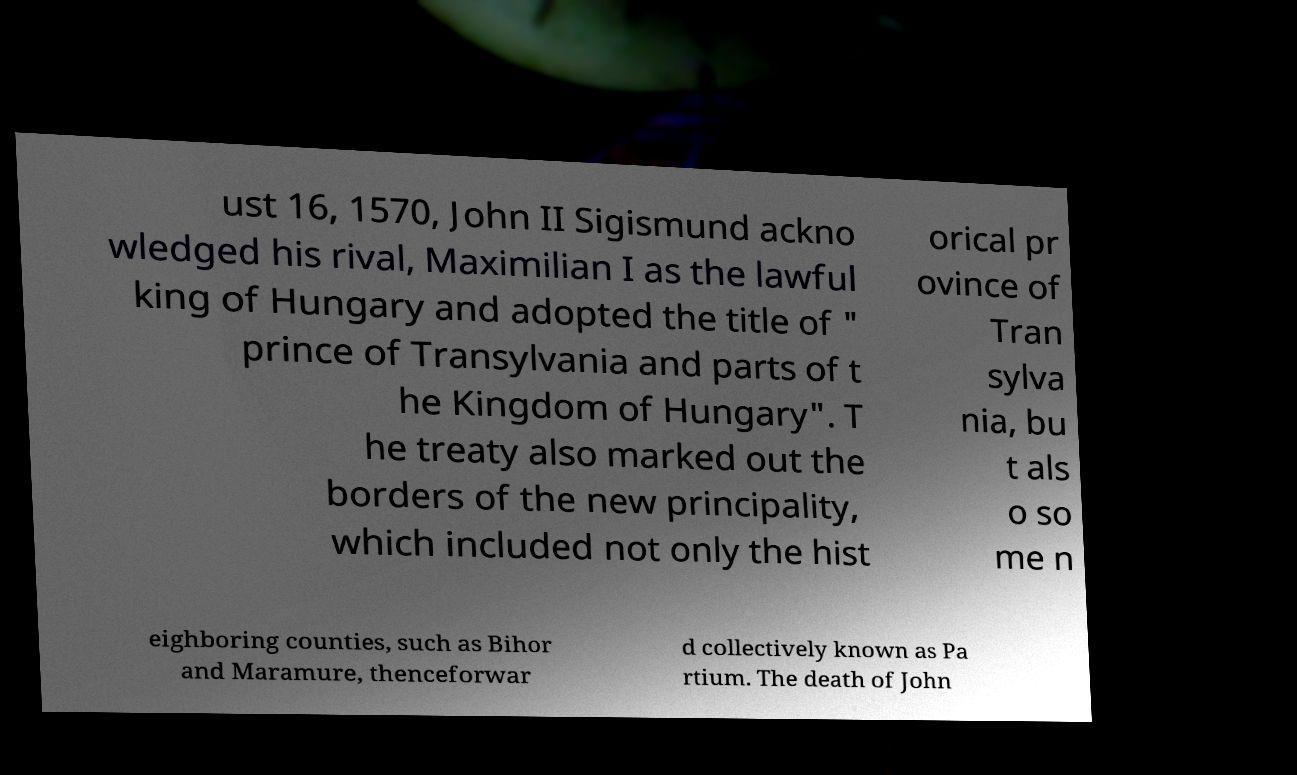There's text embedded in this image that I need extracted. Can you transcribe it verbatim? ust 16, 1570, John II Sigismund ackno wledged his rival, Maximilian I as the lawful king of Hungary and adopted the title of " prince of Transylvania and parts of t he Kingdom of Hungary". T he treaty also marked out the borders of the new principality, which included not only the hist orical pr ovince of Tran sylva nia, bu t als o so me n eighboring counties, such as Bihor and Maramure, thenceforwar d collectively known as Pa rtium. The death of John 